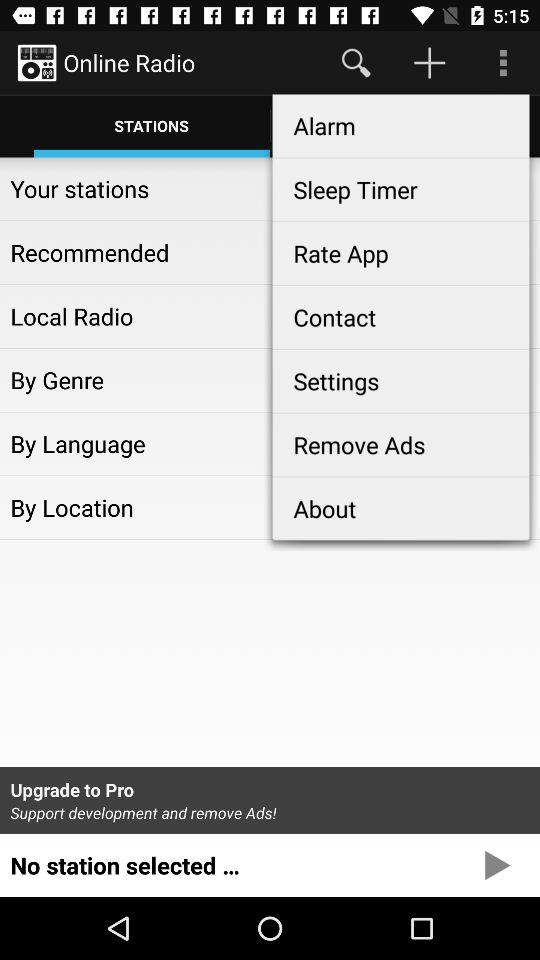What is the selected tab? The selected tab is "STATIONS". 